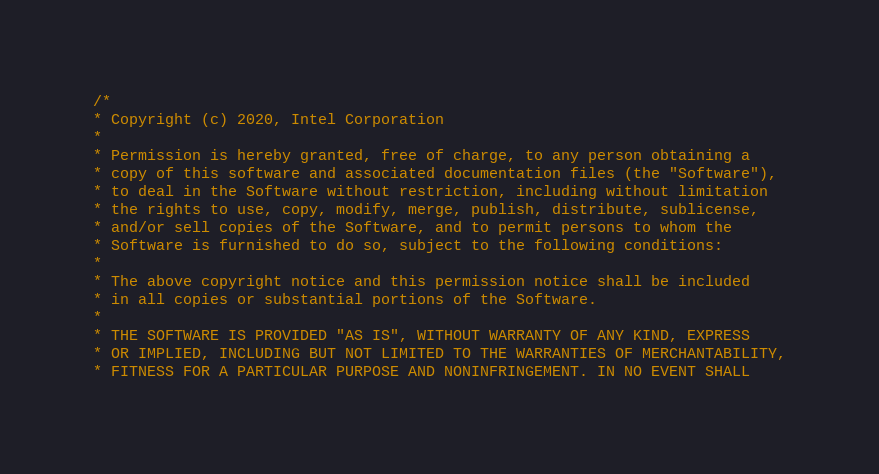Convert code to text. <code><loc_0><loc_0><loc_500><loc_500><_C++_>/*
* Copyright (c) 2020, Intel Corporation
*
* Permission is hereby granted, free of charge, to any person obtaining a
* copy of this software and associated documentation files (the "Software"),
* to deal in the Software without restriction, including without limitation
* the rights to use, copy, modify, merge, publish, distribute, sublicense,
* and/or sell copies of the Software, and to permit persons to whom the
* Software is furnished to do so, subject to the following conditions:
*
* The above copyright notice and this permission notice shall be included
* in all copies or substantial portions of the Software.
*
* THE SOFTWARE IS PROVIDED "AS IS", WITHOUT WARRANTY OF ANY KIND, EXPRESS
* OR IMPLIED, INCLUDING BUT NOT LIMITED TO THE WARRANTIES OF MERCHANTABILITY,
* FITNESS FOR A PARTICULAR PURPOSE AND NONINFRINGEMENT. IN NO EVENT SHALL</code> 